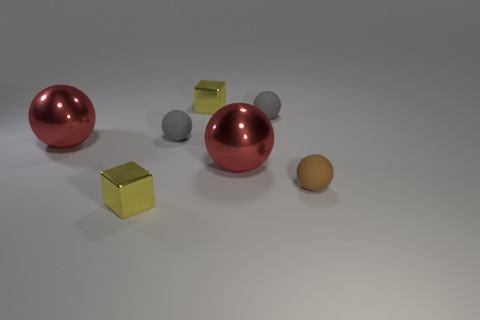There is a large metal ball that is to the left of the yellow thing behind the brown thing; what color is it?
Ensure brevity in your answer.  Red. Is the number of tiny brown matte objects in front of the tiny brown rubber sphere the same as the number of cyan rubber cubes?
Your answer should be very brief. Yes. There is a yellow thing on the right side of the yellow metal thing in front of the small brown ball; what number of tiny gray rubber spheres are behind it?
Your answer should be compact. 0. What color is the thing that is in front of the brown matte sphere?
Provide a succinct answer. Yellow. How many tiny yellow metallic things are in front of the tiny yellow metal block behind the tiny brown matte sphere?
Provide a succinct answer. 1. What is the shape of the small brown thing?
Offer a terse response. Sphere. There is a yellow object that is behind the brown matte sphere; does it have the same shape as the brown object?
Your answer should be compact. No. What shape is the small yellow object in front of the brown matte ball?
Keep it short and to the point. Cube. How many gray balls have the same size as the brown ball?
Make the answer very short. 2. What number of objects are matte balls left of the brown matte sphere or small cubes?
Offer a terse response. 4. 